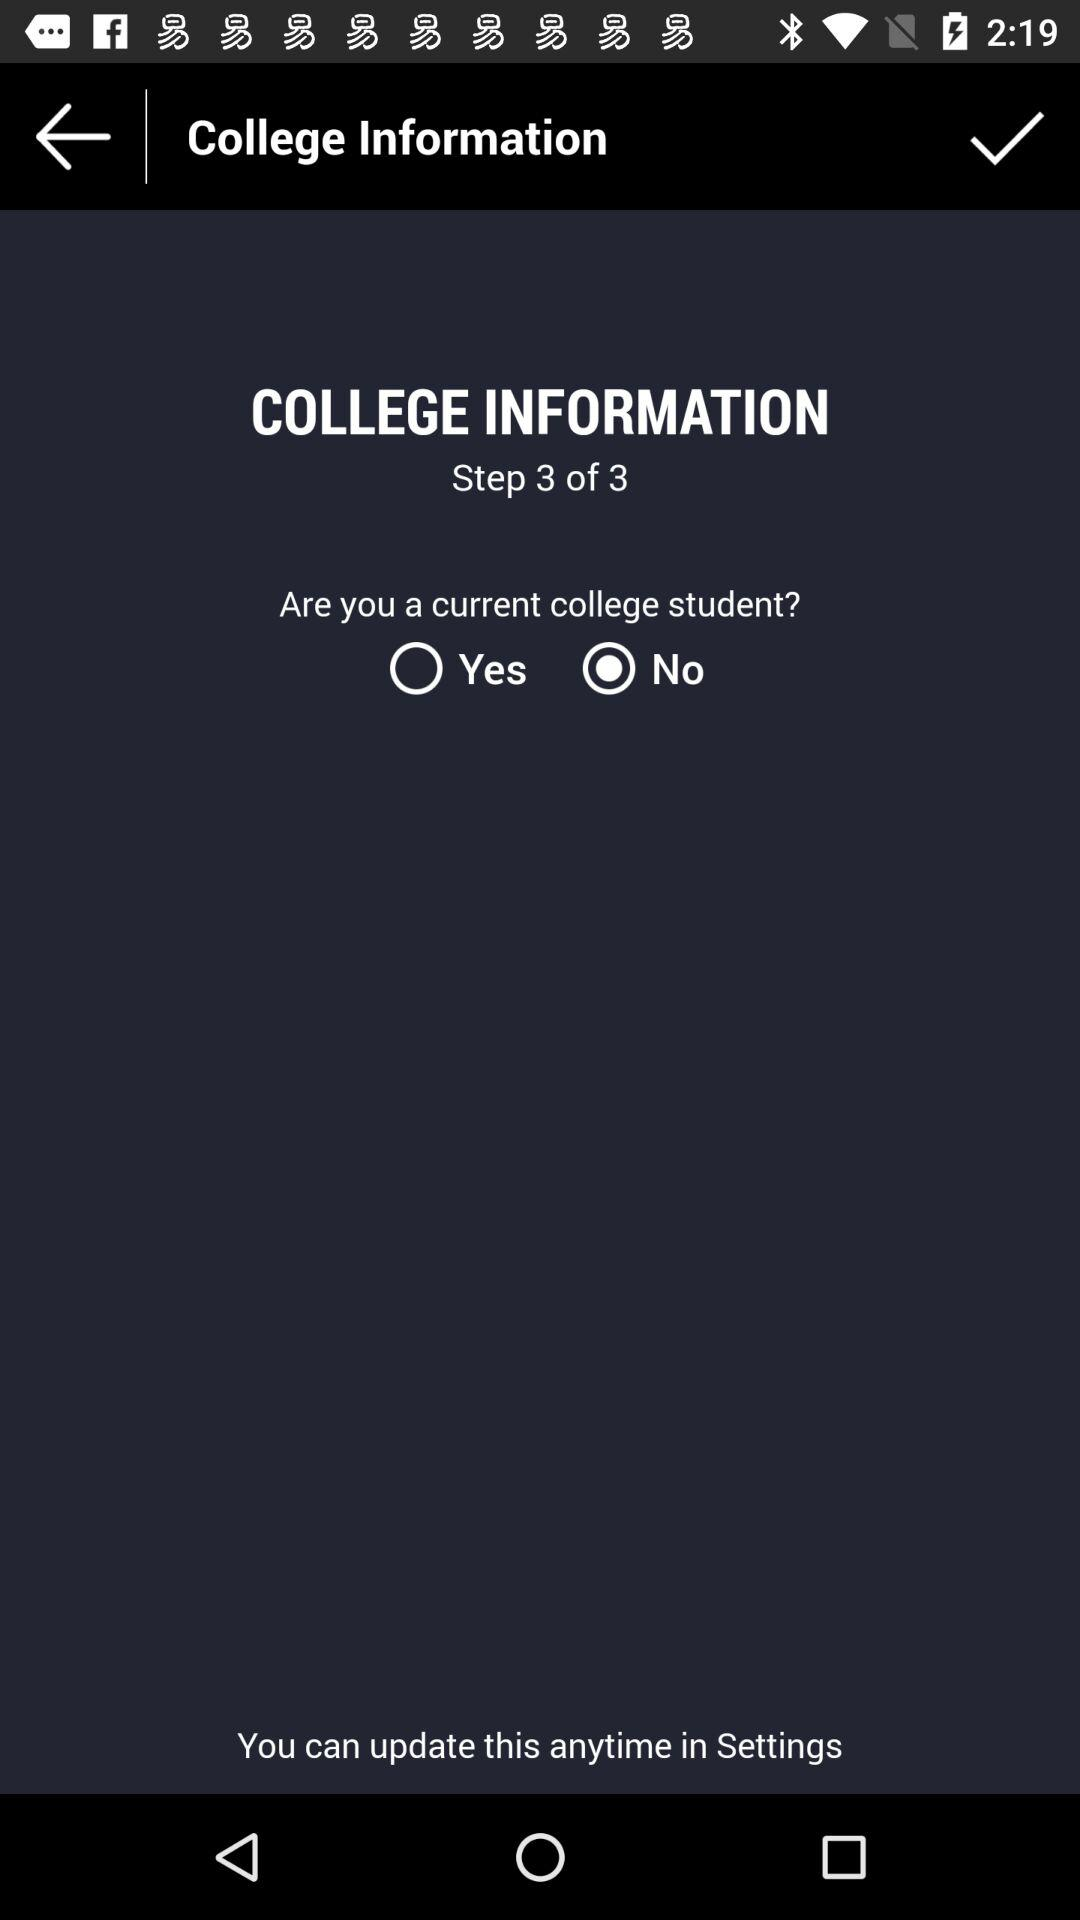How many steps are there? There are three steps. 